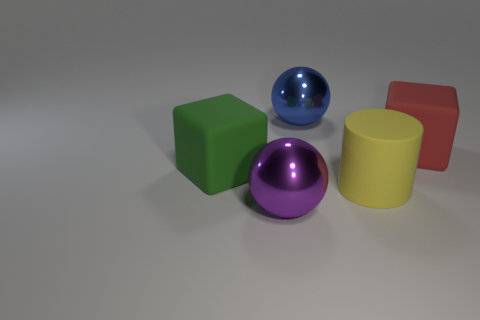Add 4 tiny cyan rubber balls. How many objects exist? 9 Subtract all cubes. How many objects are left? 3 Subtract all matte things. Subtract all large yellow matte cylinders. How many objects are left? 1 Add 1 large purple metal balls. How many large purple metal balls are left? 2 Add 2 green objects. How many green objects exist? 3 Subtract 0 gray balls. How many objects are left? 5 